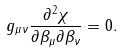Convert formula to latex. <formula><loc_0><loc_0><loc_500><loc_500>g _ { \mu \nu } \frac { \partial ^ { 2 } \chi } { \partial \beta _ { \mu } \partial \beta _ { \nu } } = 0 .</formula> 